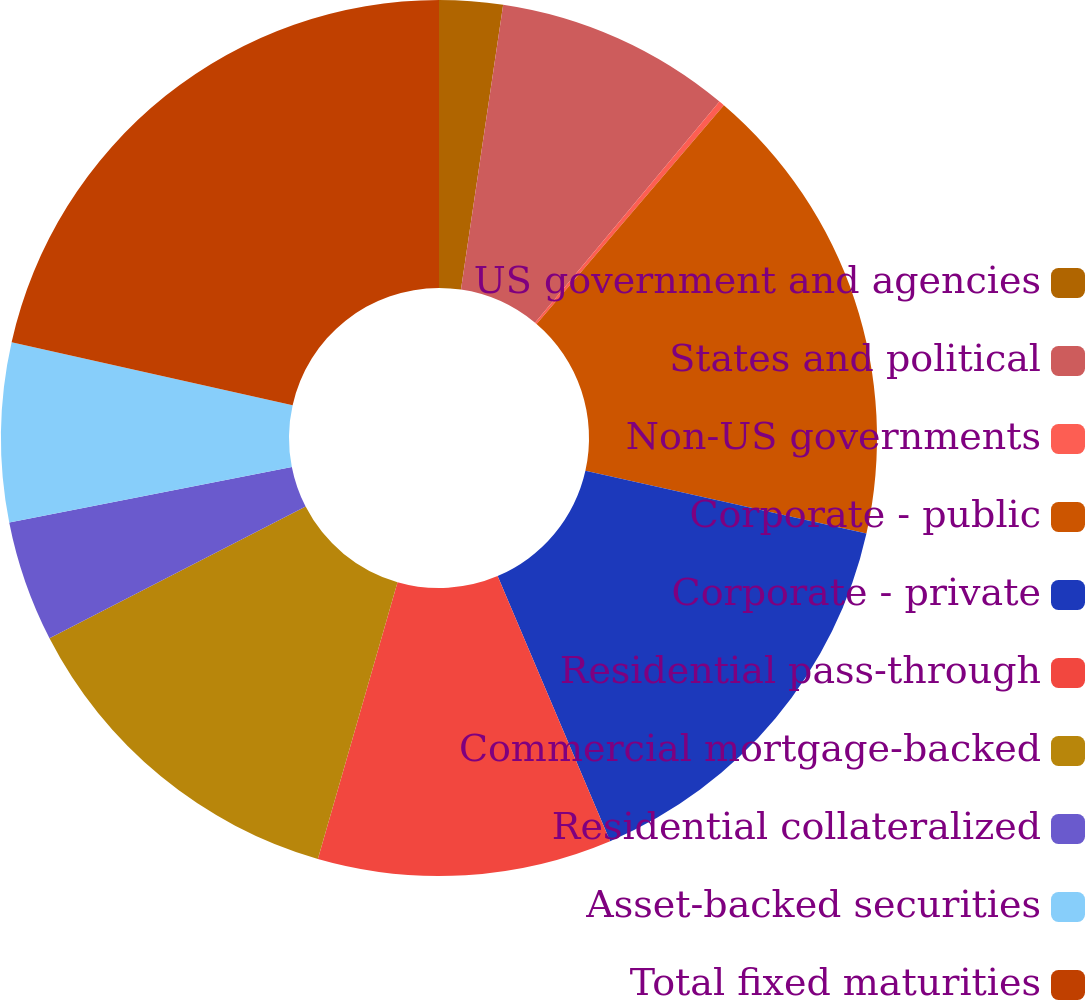<chart> <loc_0><loc_0><loc_500><loc_500><pie_chart><fcel>US government and agencies<fcel>States and political<fcel>Non-US governments<fcel>Corporate - public<fcel>Corporate - private<fcel>Residential pass-through<fcel>Commercial mortgage-backed<fcel>Residential collateralized<fcel>Asset-backed securities<fcel>Total fixed maturities<nl><fcel>2.34%<fcel>8.72%<fcel>0.21%<fcel>17.23%<fcel>15.11%<fcel>10.85%<fcel>12.98%<fcel>4.47%<fcel>6.6%<fcel>21.49%<nl></chart> 